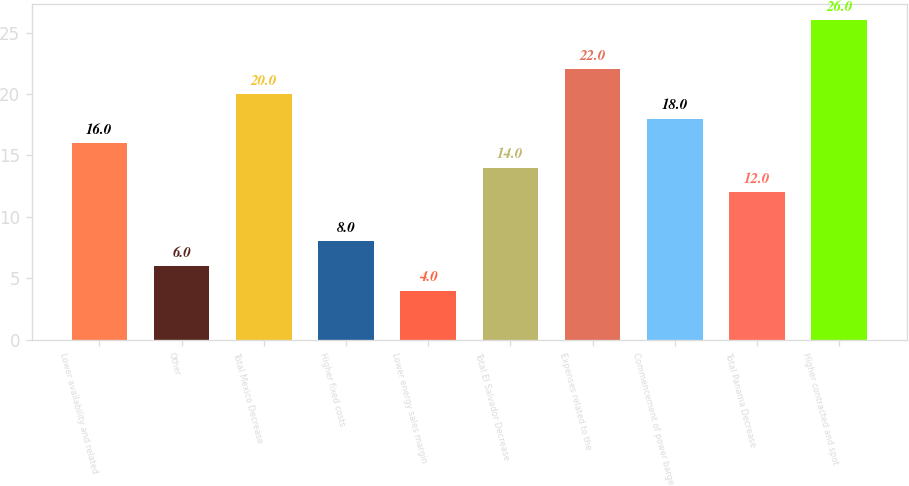Convert chart. <chart><loc_0><loc_0><loc_500><loc_500><bar_chart><fcel>Lower availability and related<fcel>Other<fcel>Total Mexico Decrease<fcel>Higher fixed costs<fcel>Lower energy sales margin<fcel>Total El Salvador Decrease<fcel>Expenses related to the<fcel>Commencement of power barge<fcel>Total Panama Decrease<fcel>Higher contracted and spot<nl><fcel>16<fcel>6<fcel>20<fcel>8<fcel>4<fcel>14<fcel>22<fcel>18<fcel>12<fcel>26<nl></chart> 